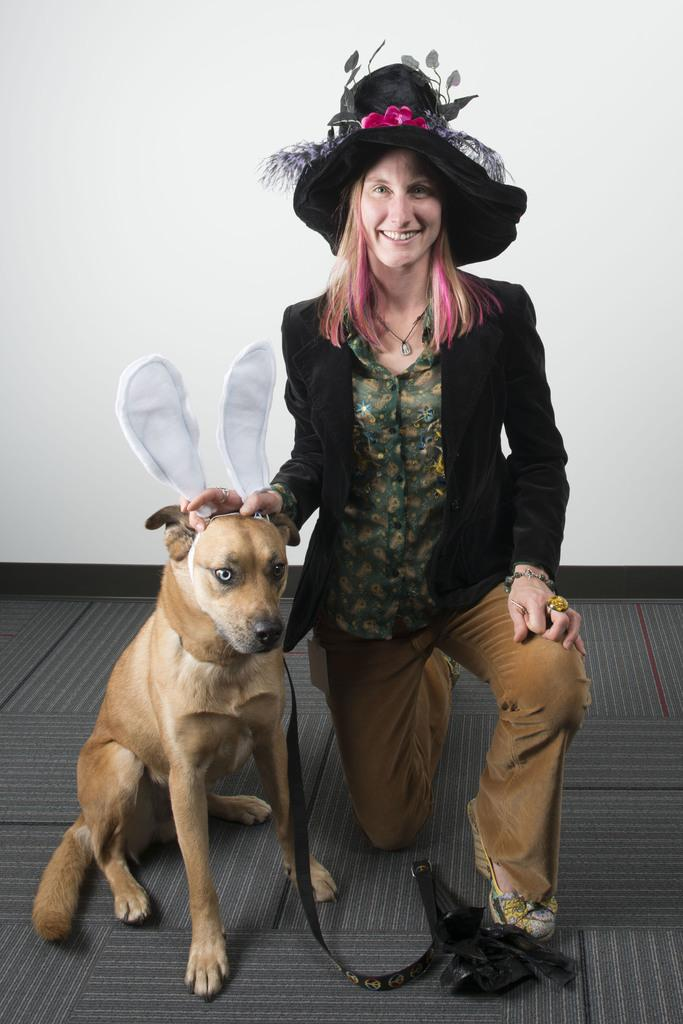Who is present in the image? There is a lady in the image. What other living creature can be seen in the image? There is a dog in the image. What is the dog wearing in the image? There is a dog belt in the image. What color is the wall behind the lady and the dog? There is a white color wall in the image. What time of day does the hour hand point to in the image? There is no clock or hour hand present in the image, so it cannot be determined from the image. 